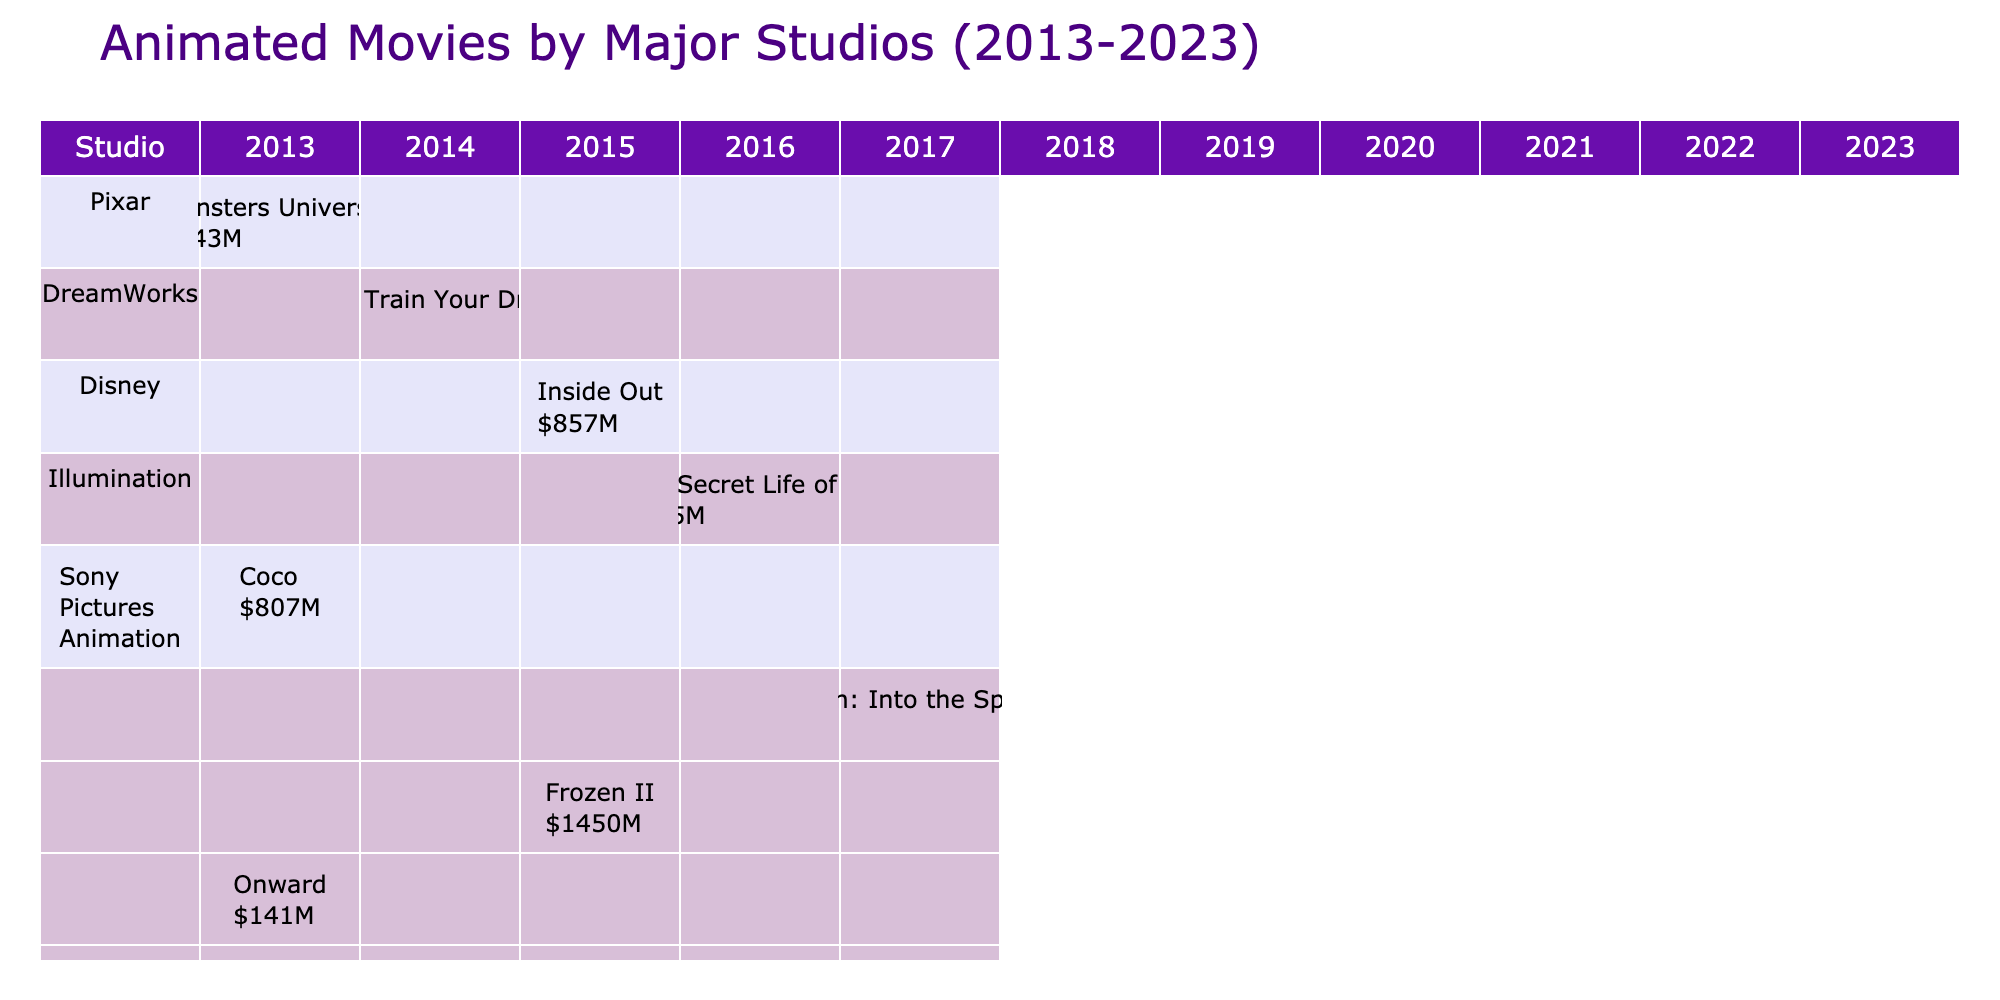What is the highest box office gross among the animated movies listed? The highest box office gross can be found by comparing the values in the "Box Office" column. The movie "Frozen II" from Disney grossed $1450 million, which is the largest value in the table.
Answer: 1450 million USD Which studio released the most movies in this table? By counting the number of entries for each studio in the table, it appears that Disney has released four movies: "Inside Out," "Frozen II," "Encanto," and "Elemental." The other studios have released fewer movies.
Answer: Disney What is the total box office revenue for Pixar movies in the table? To calculate the total box office revenue for Pixar, we can add the box office figures of all Pixar movies listed: Monsters University ($743M) + Coco ($807M) + Onward ($141M) + Elemental ($495M) = $2186M.
Answer: 2186 million USD Did Illumination release a movie in 2023? By checking the table, Illumination is not listed as having a movie in the year 2023; the only movie listed for that year is from Pixar.
Answer: No What is the difference in box office earnings between the highest and the lowest-grossing movies in the table? The highest-grossing movie is "Frozen II" with $1450 million, and the lowest is "Onward" with $141 million. The difference is calculated by subtracting the lowest from the highest: $1450M - $141M = $1309M.
Answer: 1309 million USD Which studio had a movie that grossed less than $250 million? In the table, the only movie that grossed less than $250 million is "Onward" by Pixar ($141 million) and "Encanto" by Disney ($256 million is the threshold). Hence, Pixar is the studio in question.
Answer: Pixar What was the average box office gross for DreamWorks movies listed? The table shows only two DreamWorks movies: "How to Train Your Dragon 2" ($621M) and "The Bad Guys" ($250M). To find the average, we sum the values: $621M + $250M = $871M and divide by 2, giving us $435.5M.
Answer: 435.5 million USD Which animated movie had the median box office gross among the movies listed? To find the median, first arrange the box office figures in order: 141, 250, 256, 375, 621, 743, 807, 857, 1450. There are ten movies, so take the average of the 5th and 6th values: (621 + 743)/2 = 682.
Answer: 682 million USD Which animated film released by Sony Pictures Animation is included in the table? The movie listed for Sony Pictures Animation is "Spider-Man: Into the Spider-Verse," which grossed $375 million.
Answer: Spider-Man: Into the Spider-Verse 